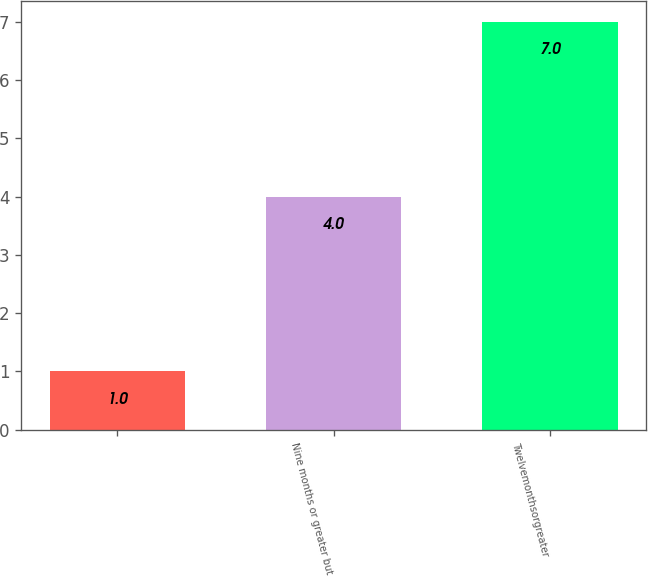Convert chart to OTSL. <chart><loc_0><loc_0><loc_500><loc_500><bar_chart><ecel><fcel>Nine months or greater but<fcel>Twelvemonthsorgreater<nl><fcel>1<fcel>4<fcel>7<nl></chart> 